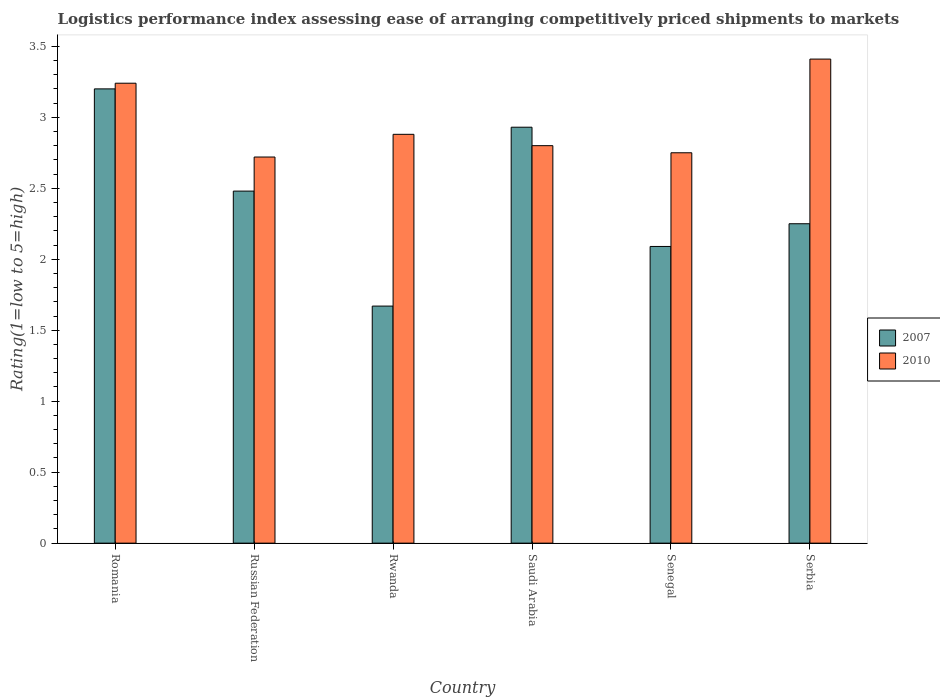How many different coloured bars are there?
Your response must be concise. 2. How many groups of bars are there?
Ensure brevity in your answer.  6. Are the number of bars on each tick of the X-axis equal?
Make the answer very short. Yes. What is the label of the 1st group of bars from the left?
Your answer should be very brief. Romania. In how many cases, is the number of bars for a given country not equal to the number of legend labels?
Give a very brief answer. 0. What is the Logistic performance index in 2007 in Russian Federation?
Keep it short and to the point. 2.48. Across all countries, what is the maximum Logistic performance index in 2007?
Offer a terse response. 3.2. Across all countries, what is the minimum Logistic performance index in 2007?
Ensure brevity in your answer.  1.67. In which country was the Logistic performance index in 2007 maximum?
Your response must be concise. Romania. In which country was the Logistic performance index in 2010 minimum?
Provide a succinct answer. Russian Federation. What is the total Logistic performance index in 2007 in the graph?
Keep it short and to the point. 14.62. What is the difference between the Logistic performance index in 2010 in Saudi Arabia and that in Serbia?
Give a very brief answer. -0.61. What is the difference between the Logistic performance index in 2007 in Senegal and the Logistic performance index in 2010 in Romania?
Your answer should be very brief. -1.15. What is the average Logistic performance index in 2010 per country?
Give a very brief answer. 2.97. What is the difference between the Logistic performance index of/in 2010 and Logistic performance index of/in 2007 in Russian Federation?
Make the answer very short. 0.24. What is the ratio of the Logistic performance index in 2007 in Rwanda to that in Serbia?
Provide a short and direct response. 0.74. Is the Logistic performance index in 2010 in Rwanda less than that in Serbia?
Your answer should be very brief. Yes. What is the difference between the highest and the second highest Logistic performance index in 2010?
Make the answer very short. 0.36. What is the difference between the highest and the lowest Logistic performance index in 2007?
Make the answer very short. 1.53. In how many countries, is the Logistic performance index in 2010 greater than the average Logistic performance index in 2010 taken over all countries?
Your answer should be very brief. 2. What does the 1st bar from the left in Rwanda represents?
Give a very brief answer. 2007. How many bars are there?
Your response must be concise. 12. Are all the bars in the graph horizontal?
Ensure brevity in your answer.  No. How many countries are there in the graph?
Give a very brief answer. 6. What is the difference between two consecutive major ticks on the Y-axis?
Give a very brief answer. 0.5. Does the graph contain grids?
Ensure brevity in your answer.  No. How many legend labels are there?
Make the answer very short. 2. How are the legend labels stacked?
Your answer should be very brief. Vertical. What is the title of the graph?
Ensure brevity in your answer.  Logistics performance index assessing ease of arranging competitively priced shipments to markets. What is the label or title of the X-axis?
Your response must be concise. Country. What is the label or title of the Y-axis?
Your answer should be very brief. Rating(1=low to 5=high). What is the Rating(1=low to 5=high) of 2007 in Romania?
Ensure brevity in your answer.  3.2. What is the Rating(1=low to 5=high) in 2010 in Romania?
Your response must be concise. 3.24. What is the Rating(1=low to 5=high) in 2007 in Russian Federation?
Provide a short and direct response. 2.48. What is the Rating(1=low to 5=high) in 2010 in Russian Federation?
Ensure brevity in your answer.  2.72. What is the Rating(1=low to 5=high) in 2007 in Rwanda?
Ensure brevity in your answer.  1.67. What is the Rating(1=low to 5=high) in 2010 in Rwanda?
Provide a short and direct response. 2.88. What is the Rating(1=low to 5=high) of 2007 in Saudi Arabia?
Your response must be concise. 2.93. What is the Rating(1=low to 5=high) in 2010 in Saudi Arabia?
Make the answer very short. 2.8. What is the Rating(1=low to 5=high) in 2007 in Senegal?
Provide a succinct answer. 2.09. What is the Rating(1=low to 5=high) in 2010 in Senegal?
Ensure brevity in your answer.  2.75. What is the Rating(1=low to 5=high) in 2007 in Serbia?
Make the answer very short. 2.25. What is the Rating(1=low to 5=high) of 2010 in Serbia?
Your response must be concise. 3.41. Across all countries, what is the maximum Rating(1=low to 5=high) of 2010?
Make the answer very short. 3.41. Across all countries, what is the minimum Rating(1=low to 5=high) of 2007?
Keep it short and to the point. 1.67. Across all countries, what is the minimum Rating(1=low to 5=high) in 2010?
Your answer should be compact. 2.72. What is the total Rating(1=low to 5=high) of 2007 in the graph?
Make the answer very short. 14.62. What is the total Rating(1=low to 5=high) of 2010 in the graph?
Your answer should be very brief. 17.8. What is the difference between the Rating(1=low to 5=high) in 2007 in Romania and that in Russian Federation?
Your answer should be very brief. 0.72. What is the difference between the Rating(1=low to 5=high) in 2010 in Romania and that in Russian Federation?
Make the answer very short. 0.52. What is the difference between the Rating(1=low to 5=high) of 2007 in Romania and that in Rwanda?
Your response must be concise. 1.53. What is the difference between the Rating(1=low to 5=high) of 2010 in Romania and that in Rwanda?
Ensure brevity in your answer.  0.36. What is the difference between the Rating(1=low to 5=high) of 2007 in Romania and that in Saudi Arabia?
Offer a terse response. 0.27. What is the difference between the Rating(1=low to 5=high) in 2010 in Romania and that in Saudi Arabia?
Keep it short and to the point. 0.44. What is the difference between the Rating(1=low to 5=high) in 2007 in Romania and that in Senegal?
Offer a terse response. 1.11. What is the difference between the Rating(1=low to 5=high) of 2010 in Romania and that in Senegal?
Provide a succinct answer. 0.49. What is the difference between the Rating(1=low to 5=high) in 2007 in Romania and that in Serbia?
Ensure brevity in your answer.  0.95. What is the difference between the Rating(1=low to 5=high) in 2010 in Romania and that in Serbia?
Ensure brevity in your answer.  -0.17. What is the difference between the Rating(1=low to 5=high) in 2007 in Russian Federation and that in Rwanda?
Your answer should be very brief. 0.81. What is the difference between the Rating(1=low to 5=high) of 2010 in Russian Federation and that in Rwanda?
Make the answer very short. -0.16. What is the difference between the Rating(1=low to 5=high) of 2007 in Russian Federation and that in Saudi Arabia?
Keep it short and to the point. -0.45. What is the difference between the Rating(1=low to 5=high) of 2010 in Russian Federation and that in Saudi Arabia?
Your answer should be very brief. -0.08. What is the difference between the Rating(1=low to 5=high) of 2007 in Russian Federation and that in Senegal?
Make the answer very short. 0.39. What is the difference between the Rating(1=low to 5=high) of 2010 in Russian Federation and that in Senegal?
Provide a succinct answer. -0.03. What is the difference between the Rating(1=low to 5=high) in 2007 in Russian Federation and that in Serbia?
Offer a terse response. 0.23. What is the difference between the Rating(1=low to 5=high) in 2010 in Russian Federation and that in Serbia?
Your response must be concise. -0.69. What is the difference between the Rating(1=low to 5=high) of 2007 in Rwanda and that in Saudi Arabia?
Ensure brevity in your answer.  -1.26. What is the difference between the Rating(1=low to 5=high) in 2010 in Rwanda and that in Saudi Arabia?
Provide a succinct answer. 0.08. What is the difference between the Rating(1=low to 5=high) of 2007 in Rwanda and that in Senegal?
Offer a very short reply. -0.42. What is the difference between the Rating(1=low to 5=high) of 2010 in Rwanda and that in Senegal?
Ensure brevity in your answer.  0.13. What is the difference between the Rating(1=low to 5=high) of 2007 in Rwanda and that in Serbia?
Provide a succinct answer. -0.58. What is the difference between the Rating(1=low to 5=high) of 2010 in Rwanda and that in Serbia?
Your answer should be very brief. -0.53. What is the difference between the Rating(1=low to 5=high) of 2007 in Saudi Arabia and that in Senegal?
Provide a short and direct response. 0.84. What is the difference between the Rating(1=low to 5=high) of 2007 in Saudi Arabia and that in Serbia?
Give a very brief answer. 0.68. What is the difference between the Rating(1=low to 5=high) in 2010 in Saudi Arabia and that in Serbia?
Ensure brevity in your answer.  -0.61. What is the difference between the Rating(1=low to 5=high) in 2007 in Senegal and that in Serbia?
Provide a short and direct response. -0.16. What is the difference between the Rating(1=low to 5=high) of 2010 in Senegal and that in Serbia?
Your answer should be very brief. -0.66. What is the difference between the Rating(1=low to 5=high) in 2007 in Romania and the Rating(1=low to 5=high) in 2010 in Russian Federation?
Your answer should be compact. 0.48. What is the difference between the Rating(1=low to 5=high) in 2007 in Romania and the Rating(1=low to 5=high) in 2010 in Rwanda?
Make the answer very short. 0.32. What is the difference between the Rating(1=low to 5=high) in 2007 in Romania and the Rating(1=low to 5=high) in 2010 in Senegal?
Your response must be concise. 0.45. What is the difference between the Rating(1=low to 5=high) of 2007 in Romania and the Rating(1=low to 5=high) of 2010 in Serbia?
Your response must be concise. -0.21. What is the difference between the Rating(1=low to 5=high) of 2007 in Russian Federation and the Rating(1=low to 5=high) of 2010 in Rwanda?
Offer a very short reply. -0.4. What is the difference between the Rating(1=low to 5=high) in 2007 in Russian Federation and the Rating(1=low to 5=high) in 2010 in Saudi Arabia?
Ensure brevity in your answer.  -0.32. What is the difference between the Rating(1=low to 5=high) in 2007 in Russian Federation and the Rating(1=low to 5=high) in 2010 in Senegal?
Keep it short and to the point. -0.27. What is the difference between the Rating(1=low to 5=high) of 2007 in Russian Federation and the Rating(1=low to 5=high) of 2010 in Serbia?
Provide a short and direct response. -0.93. What is the difference between the Rating(1=low to 5=high) of 2007 in Rwanda and the Rating(1=low to 5=high) of 2010 in Saudi Arabia?
Offer a very short reply. -1.13. What is the difference between the Rating(1=low to 5=high) in 2007 in Rwanda and the Rating(1=low to 5=high) in 2010 in Senegal?
Offer a very short reply. -1.08. What is the difference between the Rating(1=low to 5=high) in 2007 in Rwanda and the Rating(1=low to 5=high) in 2010 in Serbia?
Offer a terse response. -1.74. What is the difference between the Rating(1=low to 5=high) in 2007 in Saudi Arabia and the Rating(1=low to 5=high) in 2010 in Senegal?
Ensure brevity in your answer.  0.18. What is the difference between the Rating(1=low to 5=high) in 2007 in Saudi Arabia and the Rating(1=low to 5=high) in 2010 in Serbia?
Give a very brief answer. -0.48. What is the difference between the Rating(1=low to 5=high) in 2007 in Senegal and the Rating(1=low to 5=high) in 2010 in Serbia?
Provide a succinct answer. -1.32. What is the average Rating(1=low to 5=high) of 2007 per country?
Your response must be concise. 2.44. What is the average Rating(1=low to 5=high) of 2010 per country?
Make the answer very short. 2.97. What is the difference between the Rating(1=low to 5=high) in 2007 and Rating(1=low to 5=high) in 2010 in Romania?
Keep it short and to the point. -0.04. What is the difference between the Rating(1=low to 5=high) of 2007 and Rating(1=low to 5=high) of 2010 in Russian Federation?
Your answer should be very brief. -0.24. What is the difference between the Rating(1=low to 5=high) of 2007 and Rating(1=low to 5=high) of 2010 in Rwanda?
Give a very brief answer. -1.21. What is the difference between the Rating(1=low to 5=high) in 2007 and Rating(1=low to 5=high) in 2010 in Saudi Arabia?
Make the answer very short. 0.13. What is the difference between the Rating(1=low to 5=high) in 2007 and Rating(1=low to 5=high) in 2010 in Senegal?
Give a very brief answer. -0.66. What is the difference between the Rating(1=low to 5=high) of 2007 and Rating(1=low to 5=high) of 2010 in Serbia?
Your answer should be very brief. -1.16. What is the ratio of the Rating(1=low to 5=high) of 2007 in Romania to that in Russian Federation?
Ensure brevity in your answer.  1.29. What is the ratio of the Rating(1=low to 5=high) of 2010 in Romania to that in Russian Federation?
Your answer should be compact. 1.19. What is the ratio of the Rating(1=low to 5=high) of 2007 in Romania to that in Rwanda?
Your response must be concise. 1.92. What is the ratio of the Rating(1=low to 5=high) in 2007 in Romania to that in Saudi Arabia?
Provide a short and direct response. 1.09. What is the ratio of the Rating(1=low to 5=high) in 2010 in Romania to that in Saudi Arabia?
Make the answer very short. 1.16. What is the ratio of the Rating(1=low to 5=high) in 2007 in Romania to that in Senegal?
Give a very brief answer. 1.53. What is the ratio of the Rating(1=low to 5=high) in 2010 in Romania to that in Senegal?
Your answer should be compact. 1.18. What is the ratio of the Rating(1=low to 5=high) of 2007 in Romania to that in Serbia?
Provide a succinct answer. 1.42. What is the ratio of the Rating(1=low to 5=high) in 2010 in Romania to that in Serbia?
Offer a terse response. 0.95. What is the ratio of the Rating(1=low to 5=high) of 2007 in Russian Federation to that in Rwanda?
Ensure brevity in your answer.  1.49. What is the ratio of the Rating(1=low to 5=high) of 2010 in Russian Federation to that in Rwanda?
Ensure brevity in your answer.  0.94. What is the ratio of the Rating(1=low to 5=high) in 2007 in Russian Federation to that in Saudi Arabia?
Your answer should be very brief. 0.85. What is the ratio of the Rating(1=low to 5=high) of 2010 in Russian Federation to that in Saudi Arabia?
Your answer should be compact. 0.97. What is the ratio of the Rating(1=low to 5=high) of 2007 in Russian Federation to that in Senegal?
Offer a terse response. 1.19. What is the ratio of the Rating(1=low to 5=high) of 2010 in Russian Federation to that in Senegal?
Make the answer very short. 0.99. What is the ratio of the Rating(1=low to 5=high) in 2007 in Russian Federation to that in Serbia?
Provide a succinct answer. 1.1. What is the ratio of the Rating(1=low to 5=high) of 2010 in Russian Federation to that in Serbia?
Provide a succinct answer. 0.8. What is the ratio of the Rating(1=low to 5=high) of 2007 in Rwanda to that in Saudi Arabia?
Keep it short and to the point. 0.57. What is the ratio of the Rating(1=low to 5=high) in 2010 in Rwanda to that in Saudi Arabia?
Provide a succinct answer. 1.03. What is the ratio of the Rating(1=low to 5=high) in 2007 in Rwanda to that in Senegal?
Offer a terse response. 0.8. What is the ratio of the Rating(1=low to 5=high) in 2010 in Rwanda to that in Senegal?
Keep it short and to the point. 1.05. What is the ratio of the Rating(1=low to 5=high) in 2007 in Rwanda to that in Serbia?
Ensure brevity in your answer.  0.74. What is the ratio of the Rating(1=low to 5=high) in 2010 in Rwanda to that in Serbia?
Keep it short and to the point. 0.84. What is the ratio of the Rating(1=low to 5=high) in 2007 in Saudi Arabia to that in Senegal?
Make the answer very short. 1.4. What is the ratio of the Rating(1=low to 5=high) in 2010 in Saudi Arabia to that in Senegal?
Ensure brevity in your answer.  1.02. What is the ratio of the Rating(1=low to 5=high) in 2007 in Saudi Arabia to that in Serbia?
Your response must be concise. 1.3. What is the ratio of the Rating(1=low to 5=high) in 2010 in Saudi Arabia to that in Serbia?
Keep it short and to the point. 0.82. What is the ratio of the Rating(1=low to 5=high) of 2007 in Senegal to that in Serbia?
Make the answer very short. 0.93. What is the ratio of the Rating(1=low to 5=high) in 2010 in Senegal to that in Serbia?
Make the answer very short. 0.81. What is the difference between the highest and the second highest Rating(1=low to 5=high) in 2007?
Offer a terse response. 0.27. What is the difference between the highest and the second highest Rating(1=low to 5=high) of 2010?
Ensure brevity in your answer.  0.17. What is the difference between the highest and the lowest Rating(1=low to 5=high) of 2007?
Offer a terse response. 1.53. What is the difference between the highest and the lowest Rating(1=low to 5=high) in 2010?
Provide a succinct answer. 0.69. 